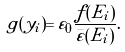Convert formula to latex. <formula><loc_0><loc_0><loc_500><loc_500>g ( y _ { i } ) = \varepsilon _ { 0 } \frac { f ( E _ { i } ) } { \bar { \varepsilon } ( E _ { i } ) } .</formula> 